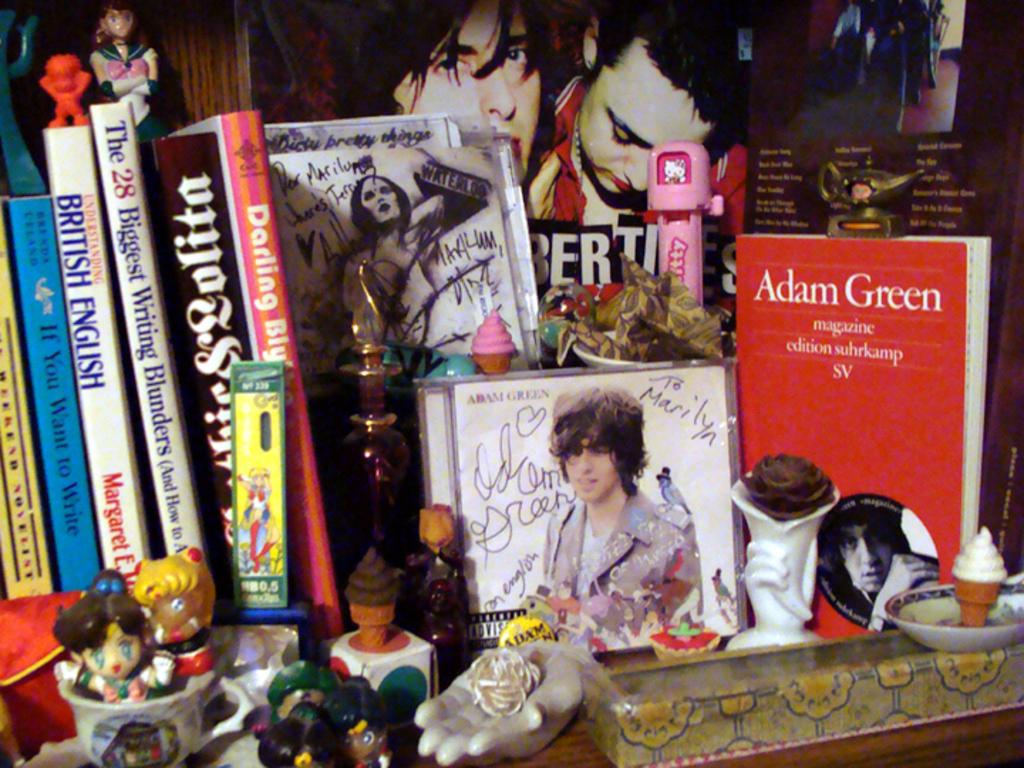What is the title of the blue book?
Give a very brief answer. If you want to write. 